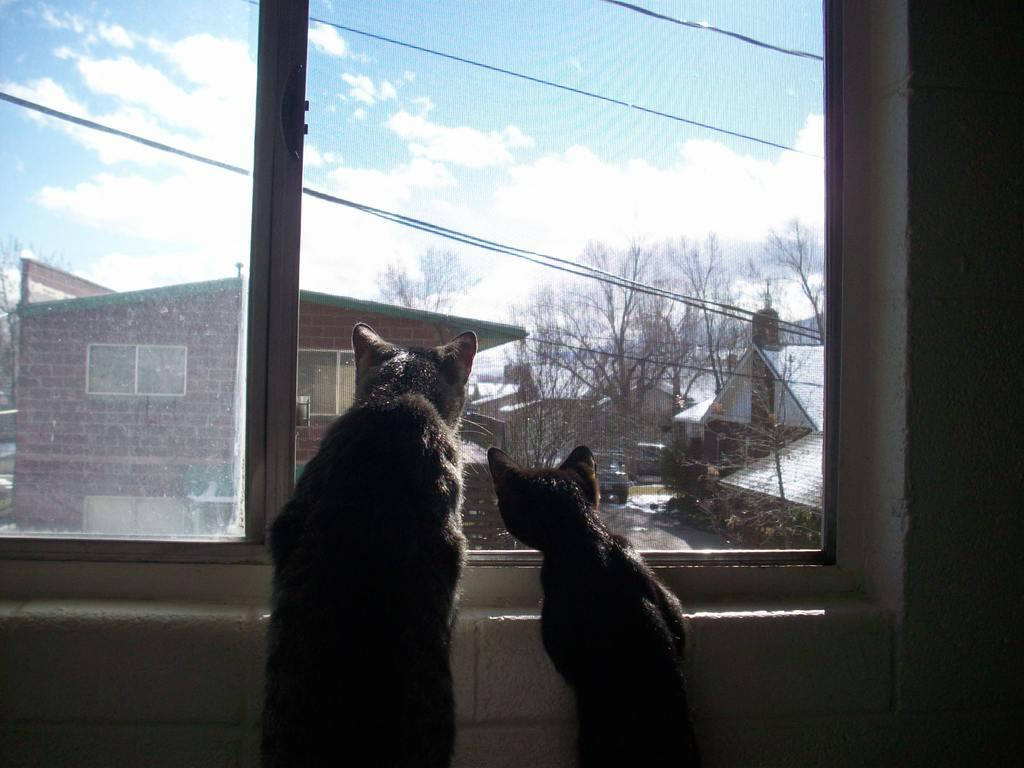What animals are in the center of the image? There are two cats in the center of the image. What can be seen in the image besides the cats? There is a window, trees, houses, wires, a car, and mountains in the background of the image. The sky is also visible at the top of the image. Can you describe the background of the image? The background of the image includes trees, houses, wires, a car, and mountains. How many houses are visible in the background? There is no specific number mentioned, but there are houses visible in the background. How many toes can be seen on the cats in the image? There is no information about the cats' toes in the image. 